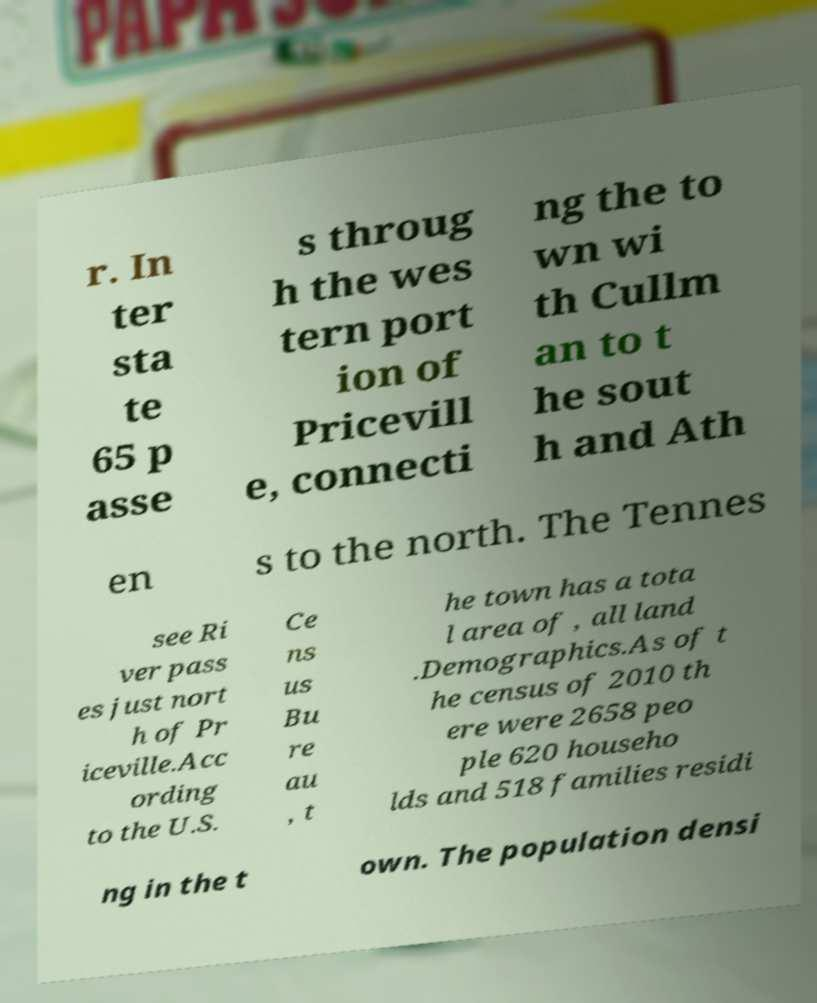Could you assist in decoding the text presented in this image and type it out clearly? r. In ter sta te 65 p asse s throug h the wes tern port ion of Pricevill e, connecti ng the to wn wi th Cullm an to t he sout h and Ath en s to the north. The Tennes see Ri ver pass es just nort h of Pr iceville.Acc ording to the U.S. Ce ns us Bu re au , t he town has a tota l area of , all land .Demographics.As of t he census of 2010 th ere were 2658 peo ple 620 househo lds and 518 families residi ng in the t own. The population densi 